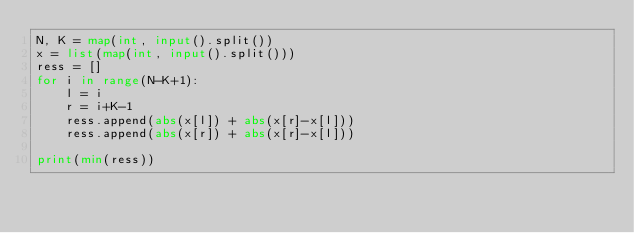<code> <loc_0><loc_0><loc_500><loc_500><_Python_>N, K = map(int, input().split())
x = list(map(int, input().split()))
ress = [] 
for i in range(N-K+1):
    l = i
    r = i+K-1
    ress.append(abs(x[l]) + abs(x[r]-x[l]))
    ress.append(abs(x[r]) + abs(x[r]-x[l]))

print(min(ress))</code> 